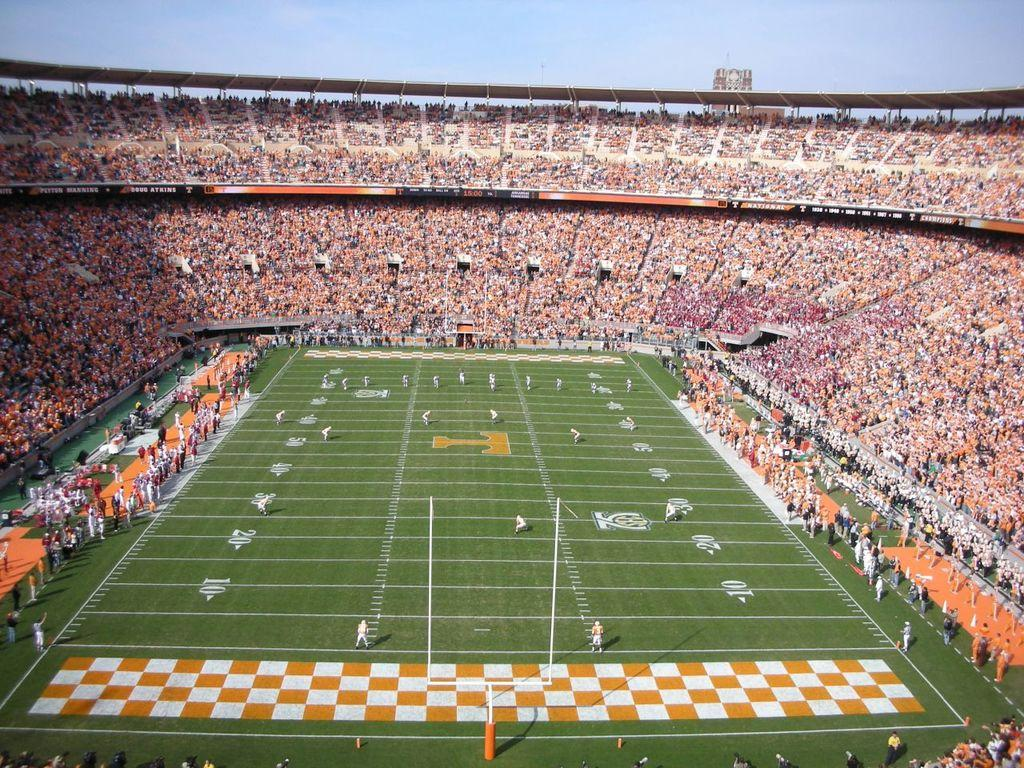<image>
Render a clear and concise summary of the photo. A football stadium full of people and we are looking out from the 10 yard line. 